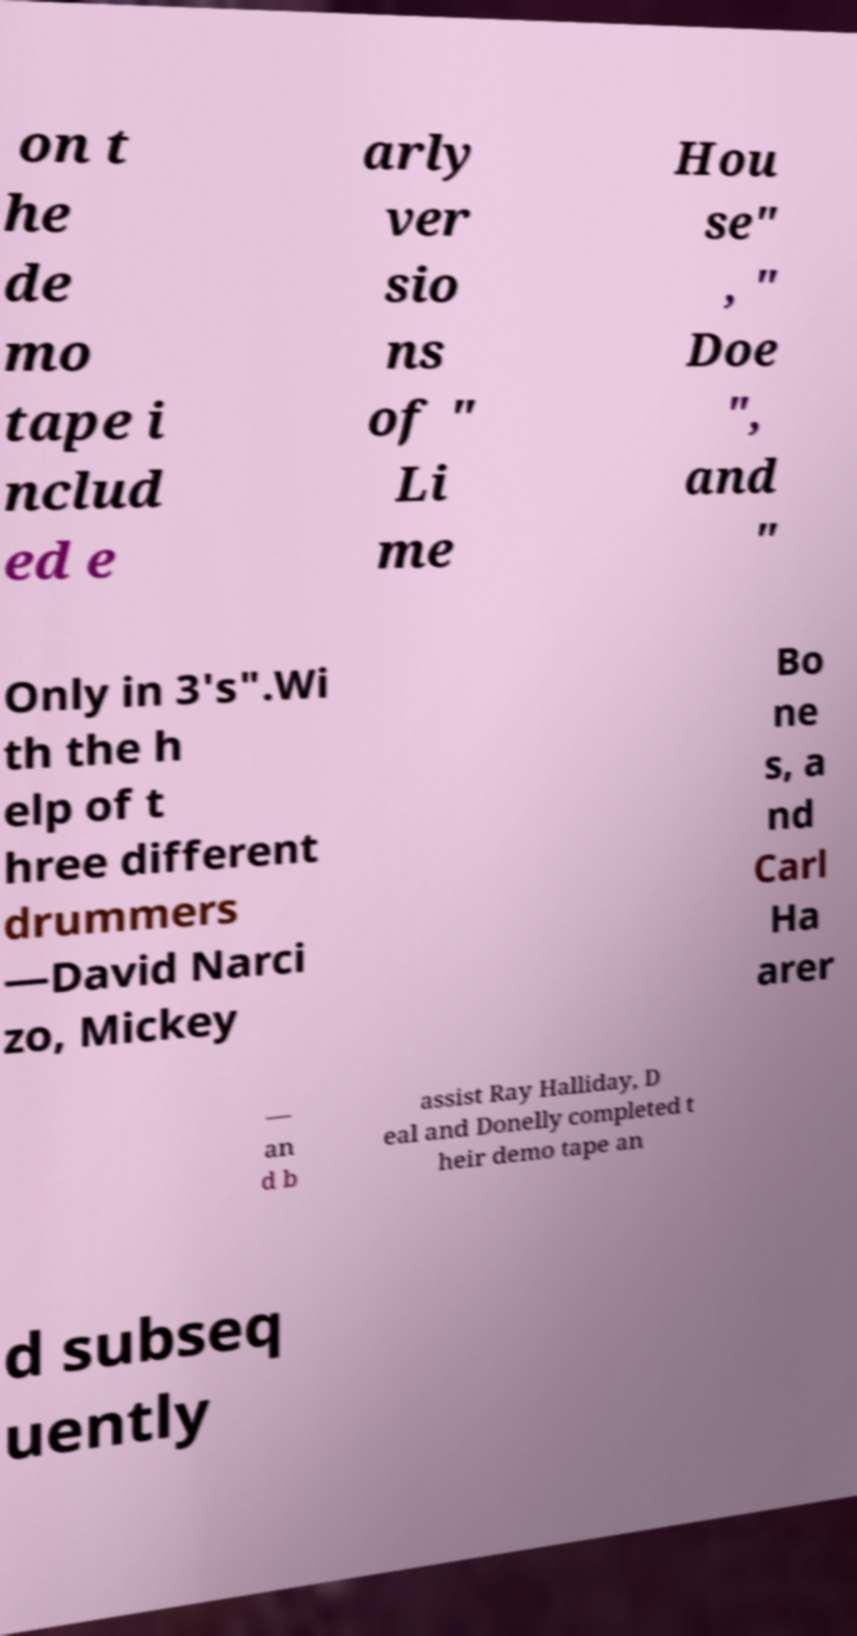Please identify and transcribe the text found in this image. on t he de mo tape i nclud ed e arly ver sio ns of " Li me Hou se" , " Doe ", and " Only in 3's".Wi th the h elp of t hree different drummers —David Narci zo, Mickey Bo ne s, a nd Carl Ha arer — an d b assist Ray Halliday, D eal and Donelly completed t heir demo tape an d subseq uently 